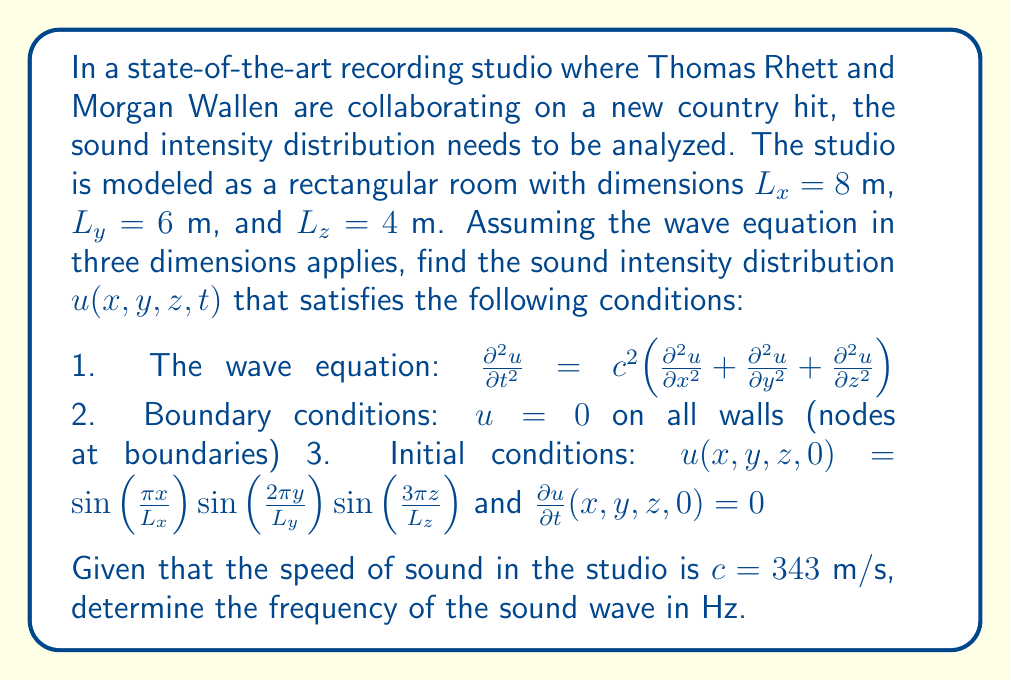Solve this math problem. Let's solve this problem step by step:

1) The general solution for the 3D wave equation with the given boundary conditions is:

   $$u(x,y,z,t) = \sum_{l,m,n=1}^{\infty} A_{lmn} \sin(\frac{l\pi x}{L_x})\sin(\frac{m\pi y}{L_y})\sin(\frac{n\pi z}{L_z})\cos(\omega_{lmn}t)$$

   where $\omega_{lmn} = c\pi\sqrt{(\frac{l}{L_x})^2 + (\frac{m}{L_y})^2 + (\frac{n}{L_z})^2}$

2) From the initial conditions, we can see that $l=1$, $m=2$, and $n=3$. All other terms in the series are zero.

3) Therefore, our solution simplifies to:

   $$u(x,y,z,t) = A \sin(\frac{\pi x}{L_x})\sin(\frac{2\pi y}{L_y})\sin(\frac{3\pi z}{L_z})\cos(\omega t)$$

   where $A = 1$ from the initial condition, and 
   
   $$\omega = c\pi\sqrt{(\frac{1}{L_x})^2 + (\frac{2}{L_y})^2 + (\frac{3}{L_z})^2}$$

4) Let's calculate $\omega$:

   $$\omega = 343\pi\sqrt{(\frac{1}{8})^2 + (\frac{2}{6})^2 + (\frac{3}{4})^2}$$
   $$= 343\pi\sqrt{0.015625 + 0.111111 + 0.5625}$$
   $$= 343\pi\sqrt{0.689236}$$
   $$= 343\pi \cdot 0.830202$$
   $$= 892.97 \text{ rad/s}$$

5) To convert angular frequency to frequency in Hz, we use $f = \frac{\omega}{2\pi}$:

   $$f = \frac{892.97}{2\pi} = 142.12 \text{ Hz}$$

Thus, the frequency of the sound wave is approximately 142.12 Hz.
Answer: 142.12 Hz 